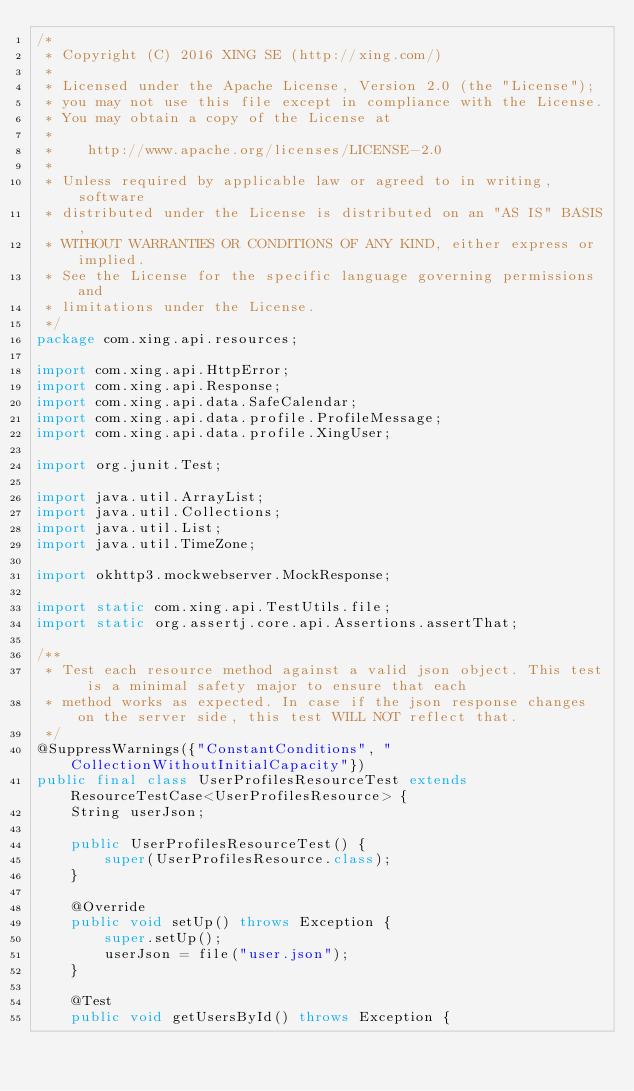<code> <loc_0><loc_0><loc_500><loc_500><_Java_>/*
 * Copyright (C) 2016 XING SE (http://xing.com/)
 *
 * Licensed under the Apache License, Version 2.0 (the "License");
 * you may not use this file except in compliance with the License.
 * You may obtain a copy of the License at
 *
 *    http://www.apache.org/licenses/LICENSE-2.0
 *
 * Unless required by applicable law or agreed to in writing, software
 * distributed under the License is distributed on an "AS IS" BASIS,
 * WITHOUT WARRANTIES OR CONDITIONS OF ANY KIND, either express or implied.
 * See the License for the specific language governing permissions and
 * limitations under the License.
 */
package com.xing.api.resources;

import com.xing.api.HttpError;
import com.xing.api.Response;
import com.xing.api.data.SafeCalendar;
import com.xing.api.data.profile.ProfileMessage;
import com.xing.api.data.profile.XingUser;

import org.junit.Test;

import java.util.ArrayList;
import java.util.Collections;
import java.util.List;
import java.util.TimeZone;

import okhttp3.mockwebserver.MockResponse;

import static com.xing.api.TestUtils.file;
import static org.assertj.core.api.Assertions.assertThat;

/**
 * Test each resource method against a valid json object. This test is a minimal safety major to ensure that each
 * method works as expected. In case if the json response changes on the server side, this test WILL NOT reflect that.
 */
@SuppressWarnings({"ConstantConditions", "CollectionWithoutInitialCapacity"})
public final class UserProfilesResourceTest extends ResourceTestCase<UserProfilesResource> {
    String userJson;

    public UserProfilesResourceTest() {
        super(UserProfilesResource.class);
    }

    @Override
    public void setUp() throws Exception {
        super.setUp();
        userJson = file("user.json");
    }

    @Test
    public void getUsersById() throws Exception {</code> 